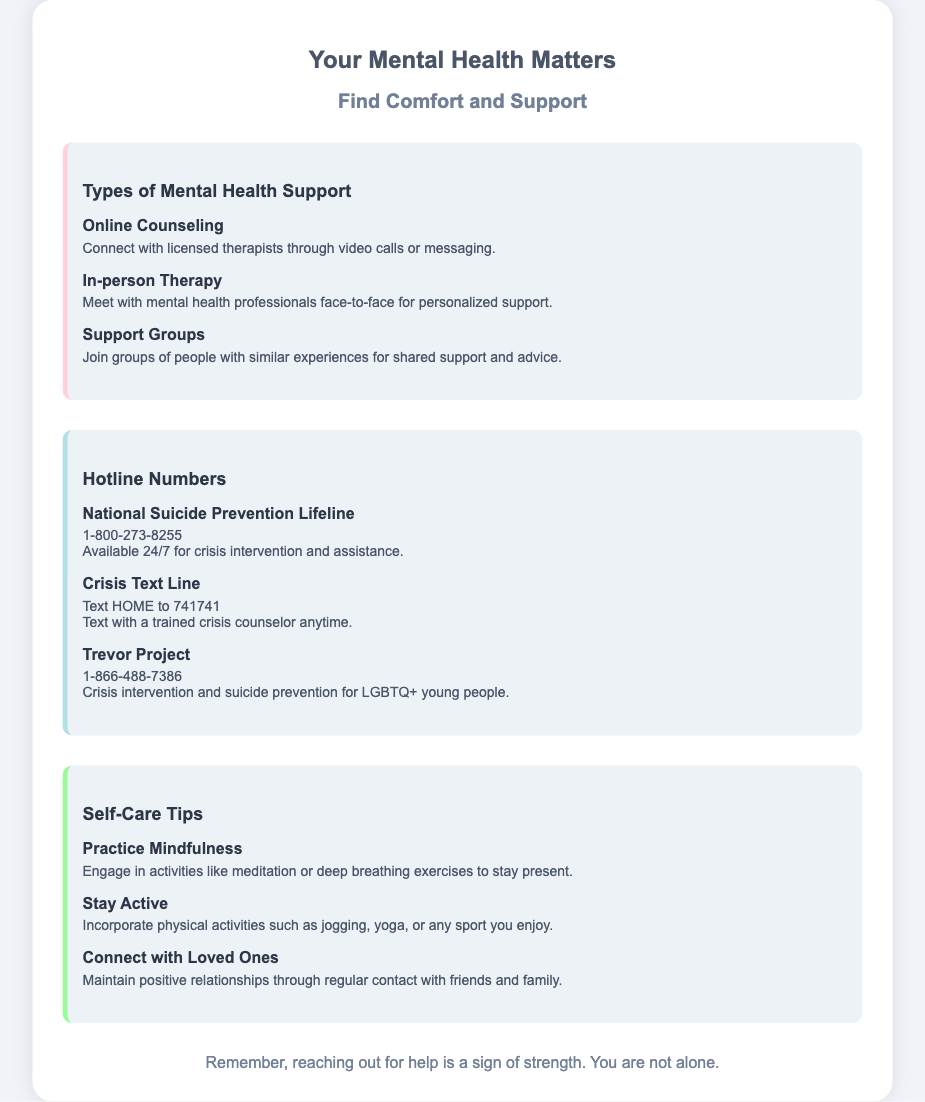What is the title of the document? The title of the document is indicated at the top of the rendered document, representing the main subject.
Answer: Your Mental Health Matters What hotline number is available 24/7? This information can be found in the section about hotline numbers, specifically indicating availability and service.
Answer: 1-800-273-8255 What type of support connects you with licensed therapists? This refers to a specific service listed under the types of mental health support provided in the document.
Answer: Online Counseling How can you text for crisis support? The document specifies a method for seeking immediate assistance via text, allowing for outreach to trained professionals.
Answer: Text HOME to 741741 What self-care tip involves meditation? This is found in the self-care tips section and focuses on a specific activity promoting mental well-being.
Answer: Practice Mindfulness What organization provides crisis intervention for LGBTQ+ young people? This is specified in the hotline numbers section, highlighting a particular service aimed at a unique demographic.
Answer: Trevor Project How should you stay active according to the document? The document provides recommendations for physical activity that can contribute to well-being.
Answer: Incorporate physical activities such as jogging, yoga, or any sport you enjoy What color theme is used in the design of the packaging? The description emphasizes a calming aesthetic, which is a key visual design element of the document.
Answer: Pastel colors 